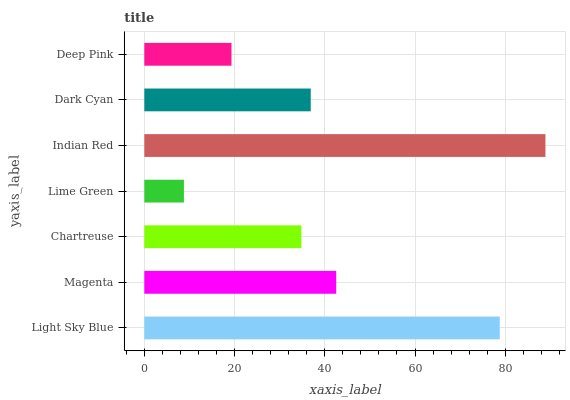Is Lime Green the minimum?
Answer yes or no. Yes. Is Indian Red the maximum?
Answer yes or no. Yes. Is Magenta the minimum?
Answer yes or no. No. Is Magenta the maximum?
Answer yes or no. No. Is Light Sky Blue greater than Magenta?
Answer yes or no. Yes. Is Magenta less than Light Sky Blue?
Answer yes or no. Yes. Is Magenta greater than Light Sky Blue?
Answer yes or no. No. Is Light Sky Blue less than Magenta?
Answer yes or no. No. Is Dark Cyan the high median?
Answer yes or no. Yes. Is Dark Cyan the low median?
Answer yes or no. Yes. Is Indian Red the high median?
Answer yes or no. No. Is Light Sky Blue the low median?
Answer yes or no. No. 